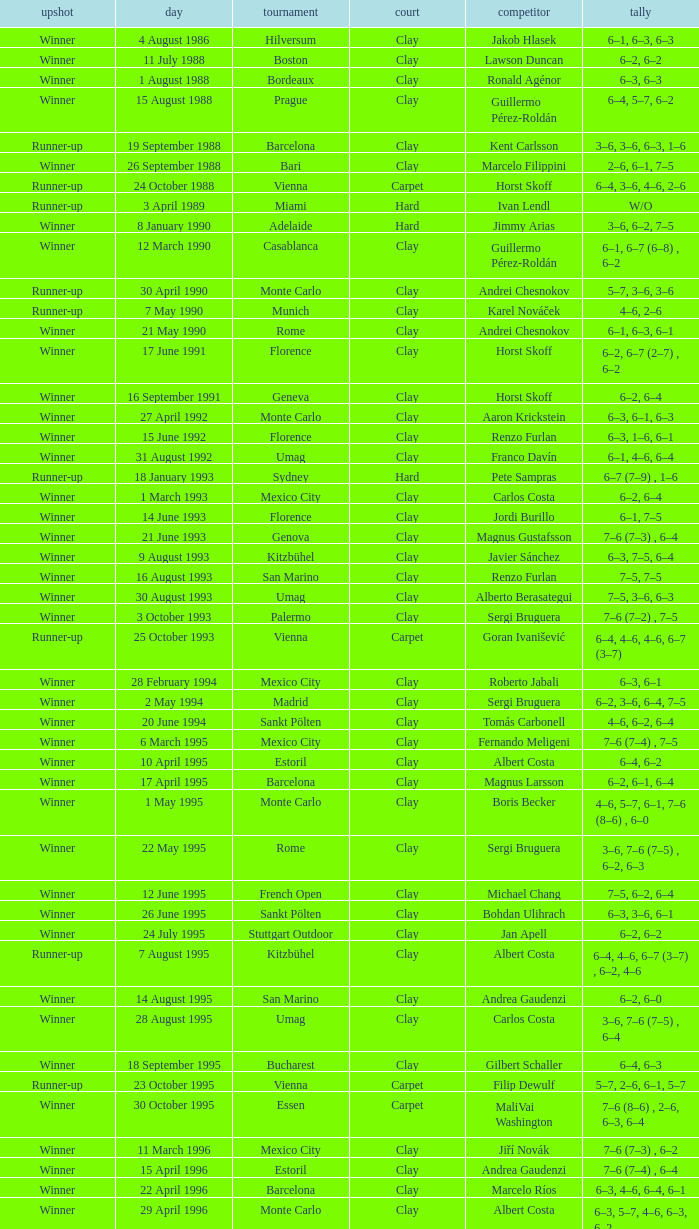What is the score when the outcome is winner against yevgeny kafelnikov? 6–2, 6–2, 6–4. 